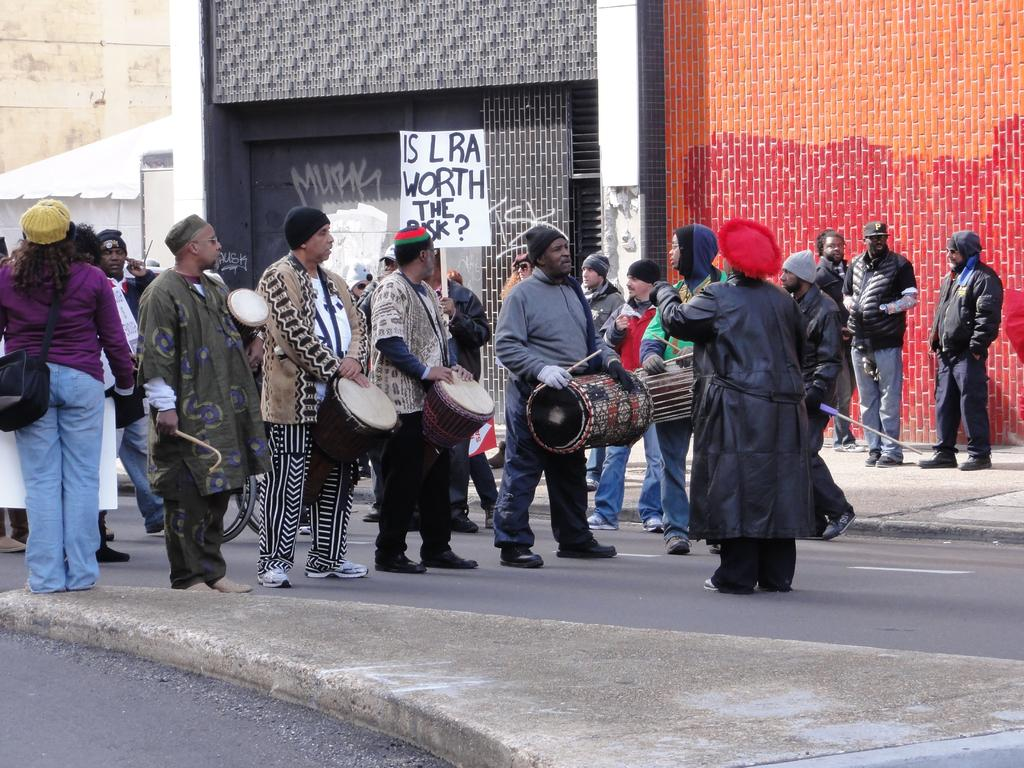Who or what can be seen in the image? There are people in the image. Where are the people located? The people are standing on the road. What are the people holding in their hands? The people are holding drums in their hands. What type of beef is being sold at the store in the image? There is no store or beef present in the image; it features people standing on the road holding drums. 